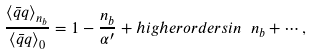<formula> <loc_0><loc_0><loc_500><loc_500>\frac { { \langle \bar { q } q \rangle } _ { n _ { b } } } { { \langle \bar { q } q \rangle } _ { 0 } } = 1 - \frac { n _ { b } } { { \alpha ^ { \prime } } } + h i g h e r o r d e r s i n \ n _ { b } + \cdots ,</formula> 